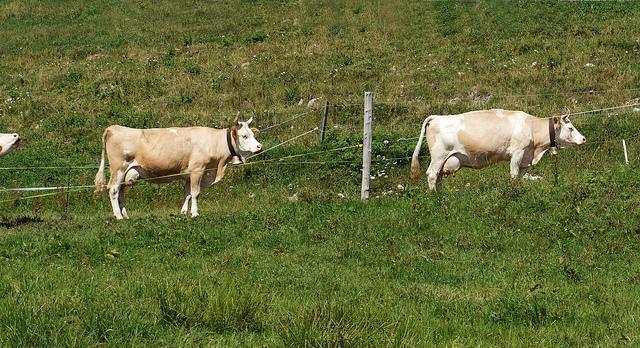How many cows are on the field?
Give a very brief answer. 2. How many cows are there?
Give a very brief answer. 3. How many cows are visible?
Give a very brief answer. 2. How many men are wearing ties?
Give a very brief answer. 0. 